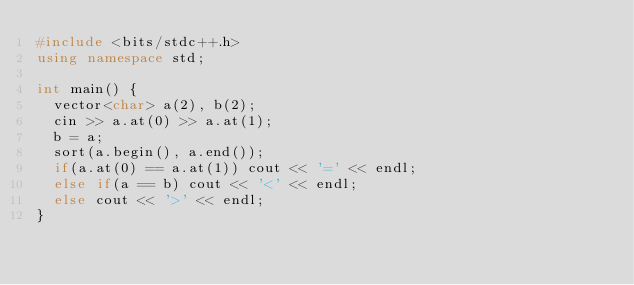<code> <loc_0><loc_0><loc_500><loc_500><_C++_>#include <bits/stdc++.h>
using namespace std;

int main() {
  vector<char> a(2), b(2);
  cin >> a.at(0) >> a.at(1);
  b = a;
  sort(a.begin(), a.end());
  if(a.at(0) == a.at(1)) cout << '=' << endl;
  else if(a == b) cout << '<' << endl;
  else cout << '>' << endl;
}
</code> 